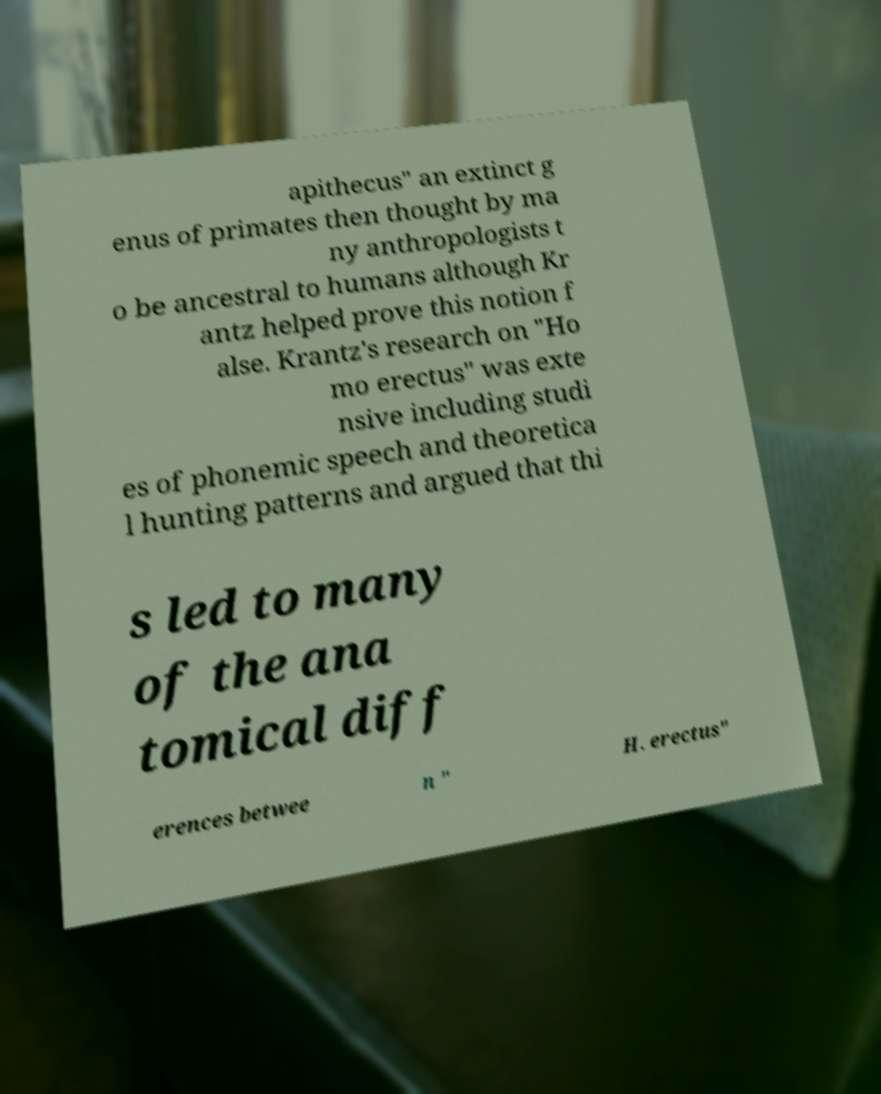For documentation purposes, I need the text within this image transcribed. Could you provide that? apithecus" an extinct g enus of primates then thought by ma ny anthropologists t o be ancestral to humans although Kr antz helped prove this notion f alse. Krantz's research on "Ho mo erectus" was exte nsive including studi es of phonemic speech and theoretica l hunting patterns and argued that thi s led to many of the ana tomical diff erences betwee n " H. erectus" 